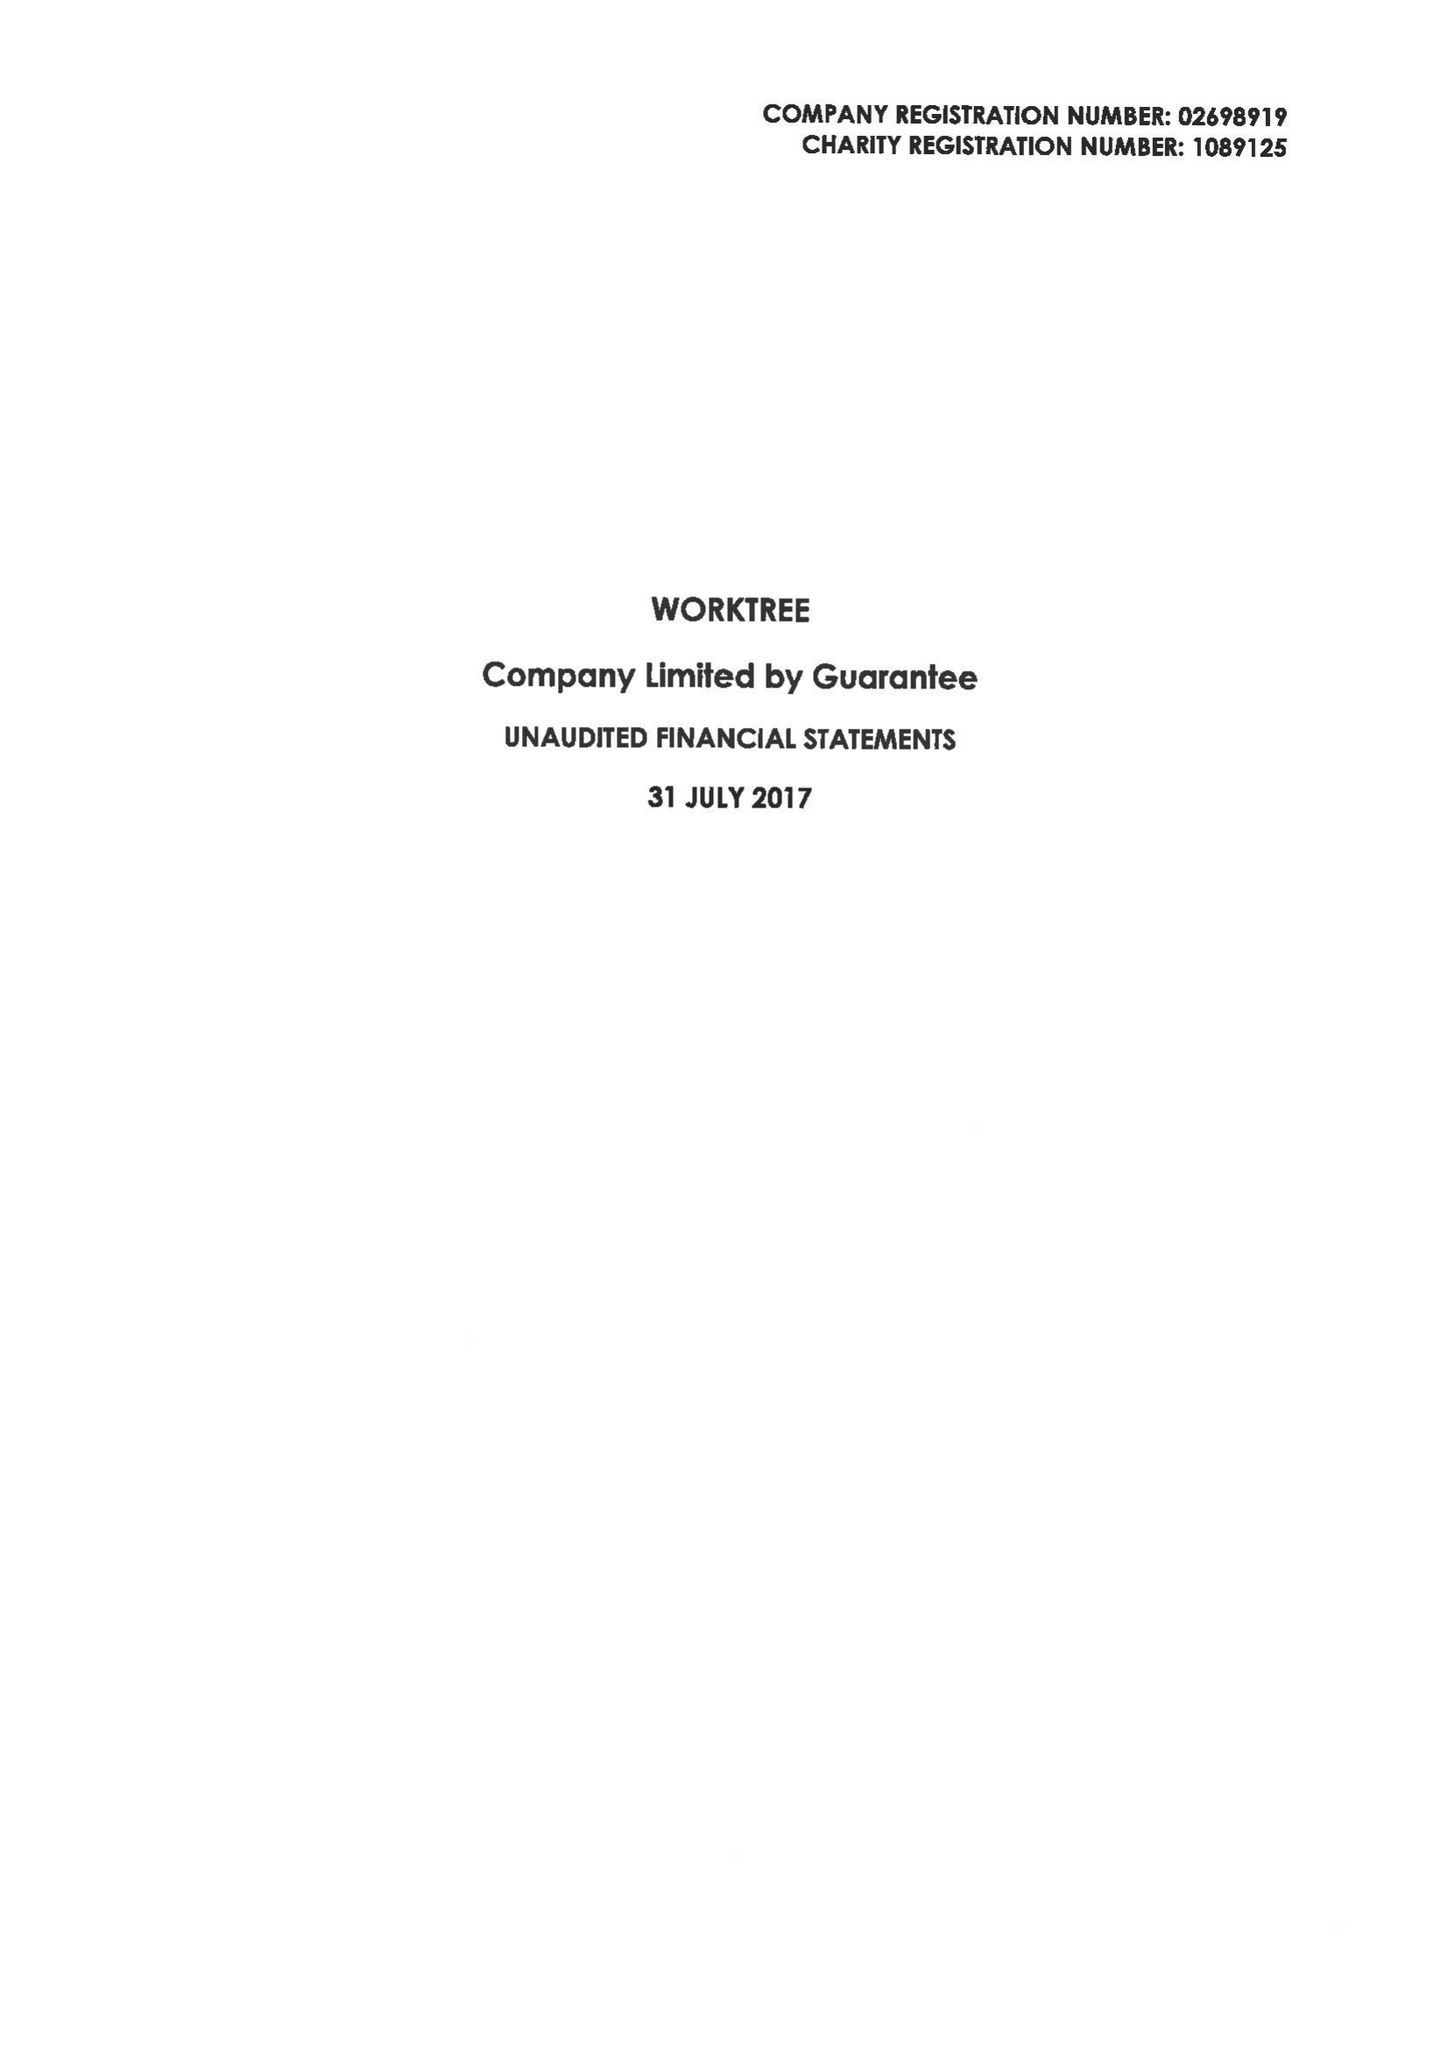What is the value for the spending_annually_in_british_pounds?
Answer the question using a single word or phrase. 82321.00 